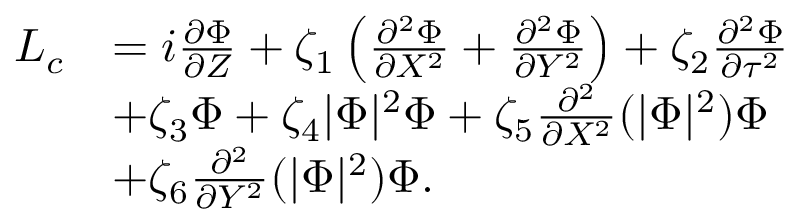Convert formula to latex. <formula><loc_0><loc_0><loc_500><loc_500>\begin{array} { r l } { { L } _ { c } } & { = i \frac { \partial \Phi } { \partial Z } + \zeta _ { 1 } \left ( \frac { \partial ^ { 2 } \Phi } { \partial X ^ { 2 } } + \frac { \partial ^ { 2 } \Phi } { \partial Y ^ { 2 } } \right ) + \zeta _ { 2 } \frac { \partial ^ { 2 } \Phi } { \partial \tau ^ { 2 } } } \\ & { + \zeta _ { 3 } \Phi + \zeta _ { 4 } | \Phi | ^ { 2 } \Phi + \zeta _ { 5 } \frac { \partial ^ { 2 } } { \partial X ^ { 2 } } ( | \Phi | ^ { 2 } ) \Phi } \\ & { + \zeta _ { 6 } \frac { \partial ^ { 2 } } { \partial Y ^ { 2 } } ( | \Phi | ^ { 2 } ) \Phi . } \end{array}</formula> 